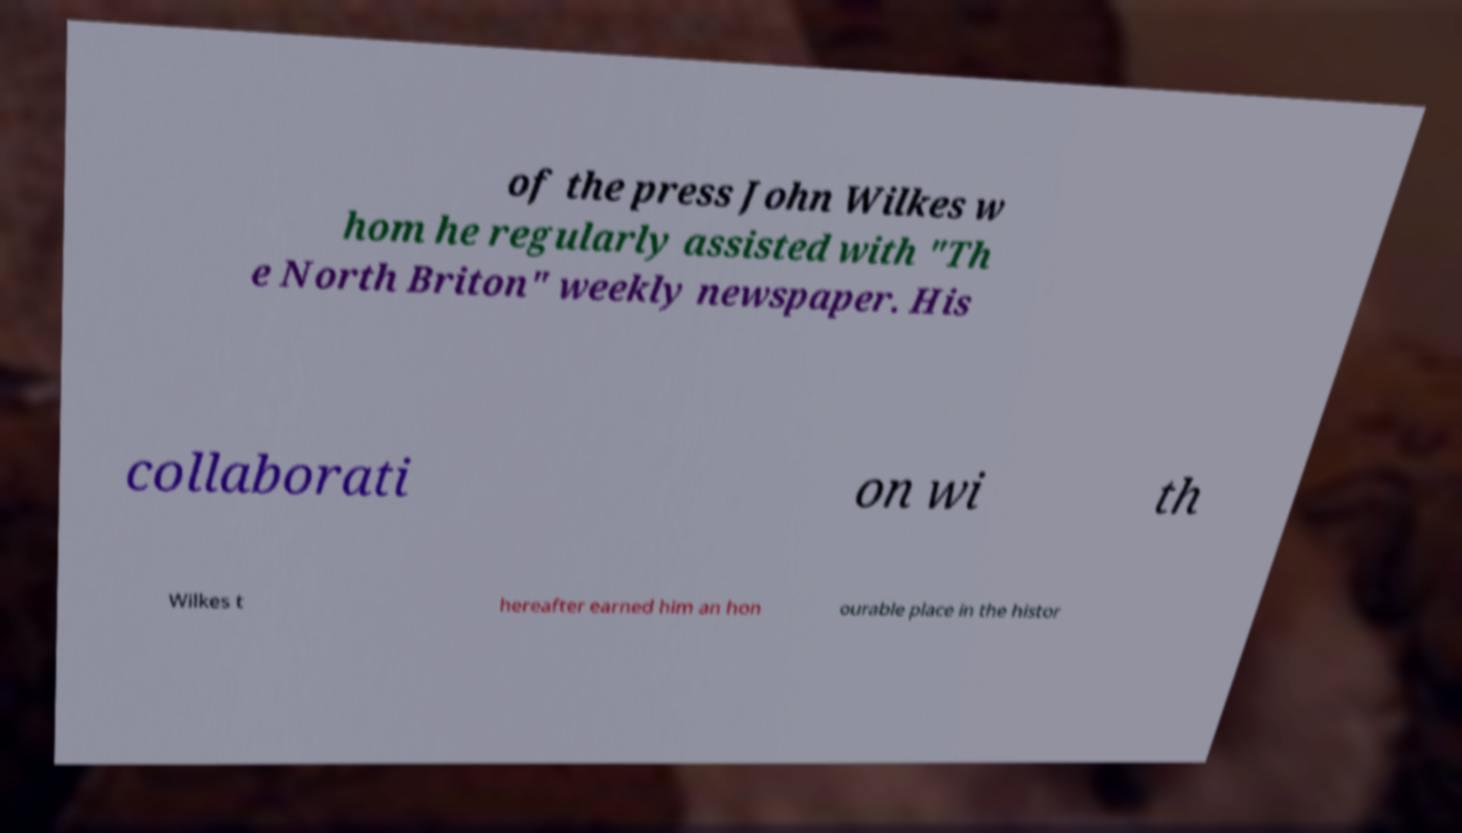What messages or text are displayed in this image? I need them in a readable, typed format. of the press John Wilkes w hom he regularly assisted with "Th e North Briton" weekly newspaper. His collaborati on wi th Wilkes t hereafter earned him an hon ourable place in the histor 